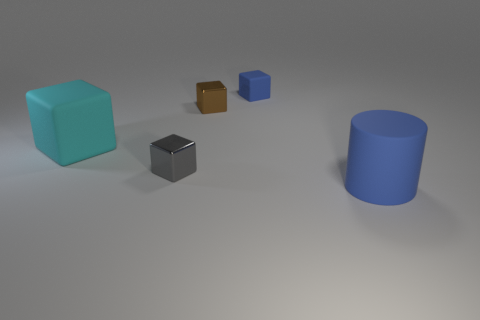What number of other objects are the same shape as the big cyan matte object?
Provide a succinct answer. 3. Is the color of the big matte object that is to the right of the blue cube the same as the small matte block?
Give a very brief answer. Yes. How many other objects are the same size as the cyan block?
Make the answer very short. 1. Are the small brown block and the big blue thing made of the same material?
Your response must be concise. No. What is the color of the big object left of the small metal cube on the left side of the brown object?
Offer a terse response. Cyan. The cyan rubber thing that is the same shape as the tiny brown metallic thing is what size?
Give a very brief answer. Large. Do the big rubber cylinder and the small matte block have the same color?
Provide a short and direct response. Yes. How many tiny blue objects are in front of the shiny cube that is in front of the matte cube that is to the left of the gray shiny object?
Your answer should be very brief. 0. Is the number of tiny objects greater than the number of things?
Provide a short and direct response. No. What number of cubes are there?
Your response must be concise. 4. 